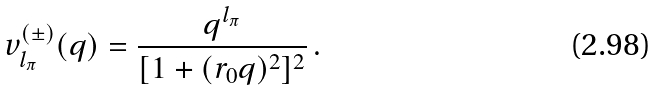Convert formula to latex. <formula><loc_0><loc_0><loc_500><loc_500>v _ { l _ { \pi } } ^ { ( \pm ) } ( q ) = \frac { q ^ { l _ { \pi } } } { [ 1 + ( r _ { 0 } q ) ^ { 2 } ] ^ { 2 } } \, .</formula> 